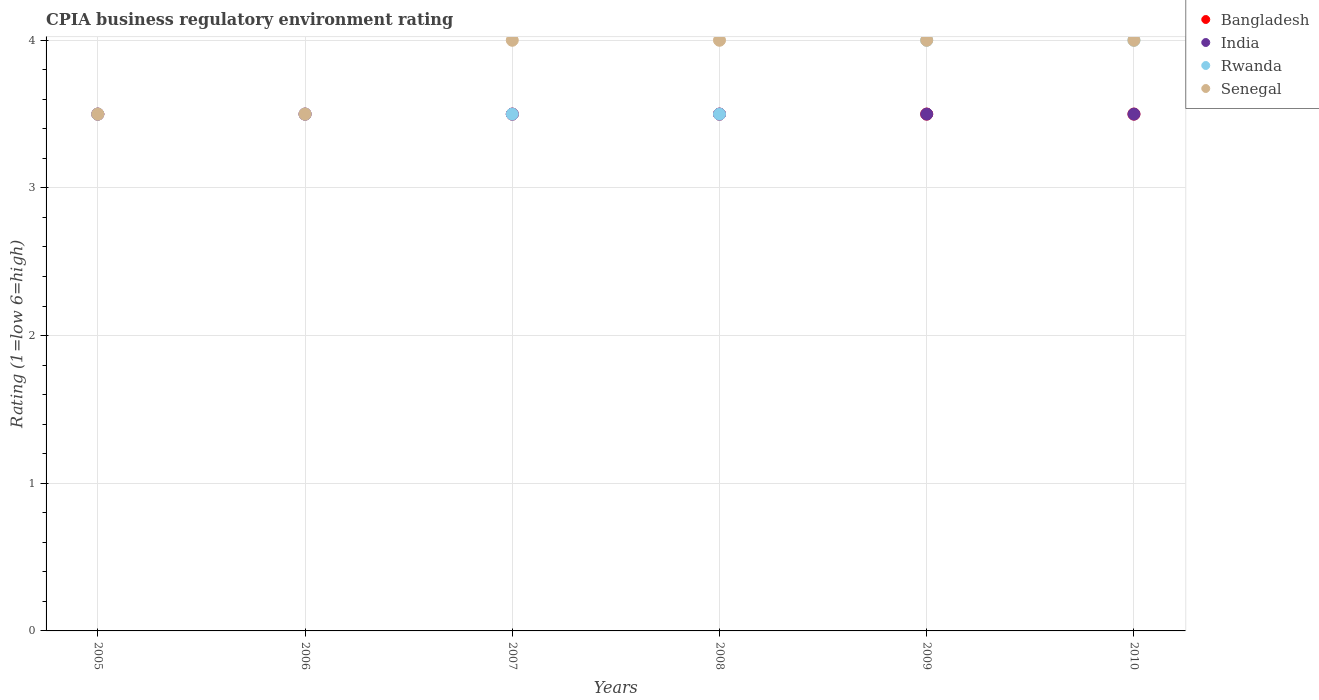How many different coloured dotlines are there?
Your response must be concise. 4. Across all years, what is the minimum CPIA rating in Senegal?
Provide a short and direct response. 3.5. In which year was the CPIA rating in India maximum?
Provide a succinct answer. 2005. In which year was the CPIA rating in Bangladesh minimum?
Provide a short and direct response. 2005. What is the difference between the CPIA rating in Bangladesh in 2005 and that in 2007?
Offer a very short reply. 0. What is the average CPIA rating in Bangladesh per year?
Provide a succinct answer. 3.5. In the year 2009, what is the difference between the CPIA rating in India and CPIA rating in Bangladesh?
Ensure brevity in your answer.  0. What is the ratio of the CPIA rating in Bangladesh in 2005 to that in 2010?
Your answer should be very brief. 1. Is the CPIA rating in India in 2007 less than that in 2009?
Provide a succinct answer. No. Is the difference between the CPIA rating in India in 2009 and 2010 greater than the difference between the CPIA rating in Bangladesh in 2009 and 2010?
Provide a short and direct response. No. Is it the case that in every year, the sum of the CPIA rating in Rwanda and CPIA rating in Bangladesh  is greater than the CPIA rating in India?
Keep it short and to the point. Yes. Does the CPIA rating in Rwanda monotonically increase over the years?
Give a very brief answer. No. How many dotlines are there?
Offer a terse response. 4. What is the difference between two consecutive major ticks on the Y-axis?
Give a very brief answer. 1. Are the values on the major ticks of Y-axis written in scientific E-notation?
Your answer should be very brief. No. Does the graph contain any zero values?
Ensure brevity in your answer.  No. Does the graph contain grids?
Provide a succinct answer. Yes. How many legend labels are there?
Offer a very short reply. 4. What is the title of the graph?
Provide a succinct answer. CPIA business regulatory environment rating. Does "Mozambique" appear as one of the legend labels in the graph?
Offer a very short reply. No. What is the label or title of the Y-axis?
Your answer should be compact. Rating (1=low 6=high). What is the Rating (1=low 6=high) in India in 2005?
Your answer should be compact. 3.5. What is the Rating (1=low 6=high) of Senegal in 2005?
Your answer should be compact. 3.5. What is the Rating (1=low 6=high) of Bangladesh in 2006?
Give a very brief answer. 3.5. What is the Rating (1=low 6=high) of India in 2006?
Provide a short and direct response. 3.5. What is the Rating (1=low 6=high) of Bangladesh in 2008?
Offer a very short reply. 3.5. What is the Rating (1=low 6=high) of Rwanda in 2008?
Offer a very short reply. 3.5. What is the Rating (1=low 6=high) of Senegal in 2008?
Offer a terse response. 4. What is the Rating (1=low 6=high) in Bangladesh in 2009?
Provide a succinct answer. 3.5. What is the Rating (1=low 6=high) of India in 2009?
Keep it short and to the point. 3.5. What is the Rating (1=low 6=high) of Rwanda in 2009?
Provide a succinct answer. 4. What is the Rating (1=low 6=high) of India in 2010?
Give a very brief answer. 3.5. What is the Rating (1=low 6=high) of Rwanda in 2010?
Keep it short and to the point. 4. Across all years, what is the maximum Rating (1=low 6=high) of Senegal?
Provide a succinct answer. 4. Across all years, what is the minimum Rating (1=low 6=high) of Bangladesh?
Provide a short and direct response. 3.5. Across all years, what is the minimum Rating (1=low 6=high) in Rwanda?
Provide a short and direct response. 3.5. What is the total Rating (1=low 6=high) of Bangladesh in the graph?
Your response must be concise. 21. What is the total Rating (1=low 6=high) of India in the graph?
Your answer should be very brief. 21. What is the total Rating (1=low 6=high) in Senegal in the graph?
Your answer should be very brief. 23. What is the difference between the Rating (1=low 6=high) in India in 2005 and that in 2006?
Your answer should be compact. 0. What is the difference between the Rating (1=low 6=high) in Bangladesh in 2005 and that in 2007?
Your answer should be compact. 0. What is the difference between the Rating (1=low 6=high) of Bangladesh in 2005 and that in 2008?
Provide a short and direct response. 0. What is the difference between the Rating (1=low 6=high) of India in 2005 and that in 2008?
Your answer should be very brief. 0. What is the difference between the Rating (1=low 6=high) of Rwanda in 2005 and that in 2008?
Ensure brevity in your answer.  0. What is the difference between the Rating (1=low 6=high) in Senegal in 2005 and that in 2008?
Give a very brief answer. -0.5. What is the difference between the Rating (1=low 6=high) of Bangladesh in 2005 and that in 2010?
Offer a terse response. 0. What is the difference between the Rating (1=low 6=high) in Rwanda in 2005 and that in 2010?
Provide a succinct answer. -0.5. What is the difference between the Rating (1=low 6=high) of India in 2006 and that in 2007?
Provide a short and direct response. 0. What is the difference between the Rating (1=low 6=high) in Bangladesh in 2006 and that in 2008?
Your response must be concise. 0. What is the difference between the Rating (1=low 6=high) of Rwanda in 2006 and that in 2008?
Your answer should be compact. 0. What is the difference between the Rating (1=low 6=high) in Senegal in 2006 and that in 2008?
Make the answer very short. -0.5. What is the difference between the Rating (1=low 6=high) of India in 2006 and that in 2009?
Your answer should be very brief. 0. What is the difference between the Rating (1=low 6=high) of Bangladesh in 2006 and that in 2010?
Your answer should be very brief. 0. What is the difference between the Rating (1=low 6=high) in Rwanda in 2006 and that in 2010?
Give a very brief answer. -0.5. What is the difference between the Rating (1=low 6=high) of Senegal in 2006 and that in 2010?
Ensure brevity in your answer.  -0.5. What is the difference between the Rating (1=low 6=high) of Bangladesh in 2007 and that in 2008?
Ensure brevity in your answer.  0. What is the difference between the Rating (1=low 6=high) in Bangladesh in 2007 and that in 2009?
Keep it short and to the point. 0. What is the difference between the Rating (1=low 6=high) in India in 2007 and that in 2009?
Make the answer very short. 0. What is the difference between the Rating (1=low 6=high) in Rwanda in 2007 and that in 2010?
Provide a succinct answer. -0.5. What is the difference between the Rating (1=low 6=high) of Senegal in 2007 and that in 2010?
Keep it short and to the point. 0. What is the difference between the Rating (1=low 6=high) of Bangladesh in 2008 and that in 2009?
Your answer should be compact. 0. What is the difference between the Rating (1=low 6=high) of Bangladesh in 2009 and that in 2010?
Offer a terse response. 0. What is the difference between the Rating (1=low 6=high) in India in 2009 and that in 2010?
Make the answer very short. 0. What is the difference between the Rating (1=low 6=high) of Rwanda in 2009 and that in 2010?
Offer a very short reply. 0. What is the difference between the Rating (1=low 6=high) of Bangladesh in 2005 and the Rating (1=low 6=high) of India in 2006?
Offer a terse response. 0. What is the difference between the Rating (1=low 6=high) of Bangladesh in 2005 and the Rating (1=low 6=high) of Rwanda in 2006?
Provide a succinct answer. 0. What is the difference between the Rating (1=low 6=high) of India in 2005 and the Rating (1=low 6=high) of Rwanda in 2006?
Make the answer very short. 0. What is the difference between the Rating (1=low 6=high) of India in 2005 and the Rating (1=low 6=high) of Senegal in 2006?
Keep it short and to the point. 0. What is the difference between the Rating (1=low 6=high) of Bangladesh in 2005 and the Rating (1=low 6=high) of Senegal in 2007?
Provide a short and direct response. -0.5. What is the difference between the Rating (1=low 6=high) of India in 2005 and the Rating (1=low 6=high) of Rwanda in 2007?
Provide a succinct answer. 0. What is the difference between the Rating (1=low 6=high) in Rwanda in 2005 and the Rating (1=low 6=high) in Senegal in 2008?
Your answer should be very brief. -0.5. What is the difference between the Rating (1=low 6=high) of Bangladesh in 2005 and the Rating (1=low 6=high) of Rwanda in 2009?
Your answer should be compact. -0.5. What is the difference between the Rating (1=low 6=high) in India in 2005 and the Rating (1=low 6=high) in Rwanda in 2009?
Your answer should be compact. -0.5. What is the difference between the Rating (1=low 6=high) in India in 2005 and the Rating (1=low 6=high) in Senegal in 2009?
Your answer should be compact. -0.5. What is the difference between the Rating (1=low 6=high) of Rwanda in 2005 and the Rating (1=low 6=high) of Senegal in 2009?
Offer a very short reply. -0.5. What is the difference between the Rating (1=low 6=high) in Bangladesh in 2005 and the Rating (1=low 6=high) in India in 2010?
Keep it short and to the point. 0. What is the difference between the Rating (1=low 6=high) of Bangladesh in 2005 and the Rating (1=low 6=high) of Senegal in 2010?
Your answer should be very brief. -0.5. What is the difference between the Rating (1=low 6=high) in India in 2005 and the Rating (1=low 6=high) in Senegal in 2010?
Offer a very short reply. -0.5. What is the difference between the Rating (1=low 6=high) in Rwanda in 2005 and the Rating (1=low 6=high) in Senegal in 2010?
Provide a short and direct response. -0.5. What is the difference between the Rating (1=low 6=high) in Bangladesh in 2006 and the Rating (1=low 6=high) in Rwanda in 2007?
Your answer should be compact. 0. What is the difference between the Rating (1=low 6=high) in Bangladesh in 2006 and the Rating (1=low 6=high) in India in 2008?
Your answer should be compact. 0. What is the difference between the Rating (1=low 6=high) of Bangladesh in 2006 and the Rating (1=low 6=high) of Senegal in 2008?
Keep it short and to the point. -0.5. What is the difference between the Rating (1=low 6=high) in Rwanda in 2006 and the Rating (1=low 6=high) in Senegal in 2008?
Your response must be concise. -0.5. What is the difference between the Rating (1=low 6=high) in Bangladesh in 2006 and the Rating (1=low 6=high) in India in 2009?
Provide a short and direct response. 0. What is the difference between the Rating (1=low 6=high) in Bangladesh in 2006 and the Rating (1=low 6=high) in Rwanda in 2009?
Provide a succinct answer. -0.5. What is the difference between the Rating (1=low 6=high) of Bangladesh in 2006 and the Rating (1=low 6=high) of Senegal in 2009?
Keep it short and to the point. -0.5. What is the difference between the Rating (1=low 6=high) of Rwanda in 2006 and the Rating (1=low 6=high) of Senegal in 2009?
Offer a very short reply. -0.5. What is the difference between the Rating (1=low 6=high) in Bangladesh in 2006 and the Rating (1=low 6=high) in India in 2010?
Give a very brief answer. 0. What is the difference between the Rating (1=low 6=high) of Bangladesh in 2006 and the Rating (1=low 6=high) of Senegal in 2010?
Give a very brief answer. -0.5. What is the difference between the Rating (1=low 6=high) of India in 2006 and the Rating (1=low 6=high) of Rwanda in 2010?
Provide a short and direct response. -0.5. What is the difference between the Rating (1=low 6=high) of Bangladesh in 2007 and the Rating (1=low 6=high) of India in 2008?
Your answer should be compact. 0. What is the difference between the Rating (1=low 6=high) of Bangladesh in 2007 and the Rating (1=low 6=high) of Rwanda in 2008?
Make the answer very short. 0. What is the difference between the Rating (1=low 6=high) in Bangladesh in 2007 and the Rating (1=low 6=high) in Senegal in 2008?
Give a very brief answer. -0.5. What is the difference between the Rating (1=low 6=high) in India in 2007 and the Rating (1=low 6=high) in Rwanda in 2008?
Offer a very short reply. 0. What is the difference between the Rating (1=low 6=high) of India in 2007 and the Rating (1=low 6=high) of Senegal in 2008?
Make the answer very short. -0.5. What is the difference between the Rating (1=low 6=high) of Bangladesh in 2007 and the Rating (1=low 6=high) of Rwanda in 2009?
Keep it short and to the point. -0.5. What is the difference between the Rating (1=low 6=high) in Bangladesh in 2007 and the Rating (1=low 6=high) in Senegal in 2009?
Give a very brief answer. -0.5. What is the difference between the Rating (1=low 6=high) in India in 2007 and the Rating (1=low 6=high) in Rwanda in 2009?
Provide a short and direct response. -0.5. What is the difference between the Rating (1=low 6=high) in India in 2007 and the Rating (1=low 6=high) in Senegal in 2009?
Your response must be concise. -0.5. What is the difference between the Rating (1=low 6=high) in Rwanda in 2007 and the Rating (1=low 6=high) in Senegal in 2009?
Make the answer very short. -0.5. What is the difference between the Rating (1=low 6=high) in Bangladesh in 2008 and the Rating (1=low 6=high) in India in 2009?
Your answer should be compact. 0. What is the difference between the Rating (1=low 6=high) of Bangladesh in 2008 and the Rating (1=low 6=high) of Rwanda in 2009?
Your answer should be compact. -0.5. What is the difference between the Rating (1=low 6=high) of Rwanda in 2008 and the Rating (1=low 6=high) of Senegal in 2009?
Make the answer very short. -0.5. What is the difference between the Rating (1=low 6=high) in Bangladesh in 2008 and the Rating (1=low 6=high) in Senegal in 2010?
Keep it short and to the point. -0.5. What is the difference between the Rating (1=low 6=high) in Rwanda in 2008 and the Rating (1=low 6=high) in Senegal in 2010?
Make the answer very short. -0.5. What is the difference between the Rating (1=low 6=high) of Bangladesh in 2009 and the Rating (1=low 6=high) of India in 2010?
Ensure brevity in your answer.  0. What is the difference between the Rating (1=low 6=high) in India in 2009 and the Rating (1=low 6=high) in Senegal in 2010?
Your answer should be very brief. -0.5. What is the difference between the Rating (1=low 6=high) in Rwanda in 2009 and the Rating (1=low 6=high) in Senegal in 2010?
Offer a terse response. 0. What is the average Rating (1=low 6=high) of Rwanda per year?
Your answer should be compact. 3.67. What is the average Rating (1=low 6=high) in Senegal per year?
Your response must be concise. 3.83. In the year 2005, what is the difference between the Rating (1=low 6=high) of Bangladesh and Rating (1=low 6=high) of Rwanda?
Provide a succinct answer. 0. In the year 2005, what is the difference between the Rating (1=low 6=high) of India and Rating (1=low 6=high) of Senegal?
Your answer should be compact. 0. In the year 2006, what is the difference between the Rating (1=low 6=high) in Bangladesh and Rating (1=low 6=high) in India?
Your response must be concise. 0. In the year 2006, what is the difference between the Rating (1=low 6=high) in Bangladesh and Rating (1=low 6=high) in Senegal?
Offer a very short reply. 0. In the year 2007, what is the difference between the Rating (1=low 6=high) of Bangladesh and Rating (1=low 6=high) of Rwanda?
Your answer should be very brief. 0. In the year 2007, what is the difference between the Rating (1=low 6=high) of Bangladesh and Rating (1=low 6=high) of Senegal?
Your answer should be compact. -0.5. In the year 2007, what is the difference between the Rating (1=low 6=high) in India and Rating (1=low 6=high) in Senegal?
Provide a short and direct response. -0.5. In the year 2008, what is the difference between the Rating (1=low 6=high) of Bangladesh and Rating (1=low 6=high) of Rwanda?
Your answer should be very brief. 0. In the year 2008, what is the difference between the Rating (1=low 6=high) of Rwanda and Rating (1=low 6=high) of Senegal?
Your response must be concise. -0.5. In the year 2009, what is the difference between the Rating (1=low 6=high) in Bangladesh and Rating (1=low 6=high) in India?
Keep it short and to the point. 0. In the year 2009, what is the difference between the Rating (1=low 6=high) of India and Rating (1=low 6=high) of Senegal?
Offer a very short reply. -0.5. In the year 2009, what is the difference between the Rating (1=low 6=high) of Rwanda and Rating (1=low 6=high) of Senegal?
Give a very brief answer. 0. In the year 2010, what is the difference between the Rating (1=low 6=high) of Bangladesh and Rating (1=low 6=high) of Senegal?
Offer a terse response. -0.5. What is the ratio of the Rating (1=low 6=high) of Bangladesh in 2005 to that in 2006?
Your answer should be very brief. 1. What is the ratio of the Rating (1=low 6=high) in India in 2005 to that in 2006?
Ensure brevity in your answer.  1. What is the ratio of the Rating (1=low 6=high) in Rwanda in 2005 to that in 2006?
Make the answer very short. 1. What is the ratio of the Rating (1=low 6=high) in Senegal in 2005 to that in 2006?
Offer a terse response. 1. What is the ratio of the Rating (1=low 6=high) of Bangladesh in 2005 to that in 2007?
Your response must be concise. 1. What is the ratio of the Rating (1=low 6=high) of Senegal in 2005 to that in 2008?
Your answer should be very brief. 0.88. What is the ratio of the Rating (1=low 6=high) in Bangladesh in 2005 to that in 2009?
Keep it short and to the point. 1. What is the ratio of the Rating (1=low 6=high) in India in 2005 to that in 2009?
Make the answer very short. 1. What is the ratio of the Rating (1=low 6=high) in Senegal in 2005 to that in 2009?
Offer a very short reply. 0.88. What is the ratio of the Rating (1=low 6=high) in India in 2005 to that in 2010?
Keep it short and to the point. 1. What is the ratio of the Rating (1=low 6=high) of Bangladesh in 2006 to that in 2007?
Ensure brevity in your answer.  1. What is the ratio of the Rating (1=low 6=high) in India in 2006 to that in 2007?
Your answer should be very brief. 1. What is the ratio of the Rating (1=low 6=high) in Bangladesh in 2006 to that in 2008?
Make the answer very short. 1. What is the ratio of the Rating (1=low 6=high) of India in 2006 to that in 2008?
Your response must be concise. 1. What is the ratio of the Rating (1=low 6=high) in Senegal in 2006 to that in 2008?
Your answer should be very brief. 0.88. What is the ratio of the Rating (1=low 6=high) in India in 2006 to that in 2009?
Offer a very short reply. 1. What is the ratio of the Rating (1=low 6=high) of Senegal in 2006 to that in 2009?
Make the answer very short. 0.88. What is the ratio of the Rating (1=low 6=high) of Bangladesh in 2007 to that in 2008?
Provide a succinct answer. 1. What is the ratio of the Rating (1=low 6=high) of Rwanda in 2007 to that in 2008?
Give a very brief answer. 1. What is the ratio of the Rating (1=low 6=high) in Bangladesh in 2007 to that in 2009?
Your response must be concise. 1. What is the ratio of the Rating (1=low 6=high) of Rwanda in 2007 to that in 2009?
Provide a succinct answer. 0.88. What is the ratio of the Rating (1=low 6=high) of Senegal in 2007 to that in 2009?
Your response must be concise. 1. What is the ratio of the Rating (1=low 6=high) of Bangladesh in 2008 to that in 2009?
Your response must be concise. 1. What is the ratio of the Rating (1=low 6=high) of Senegal in 2008 to that in 2010?
Your response must be concise. 1. What is the ratio of the Rating (1=low 6=high) of Bangladesh in 2009 to that in 2010?
Your answer should be very brief. 1. What is the ratio of the Rating (1=low 6=high) in Senegal in 2009 to that in 2010?
Your answer should be compact. 1. What is the difference between the highest and the second highest Rating (1=low 6=high) of Rwanda?
Your response must be concise. 0. What is the difference between the highest and the second highest Rating (1=low 6=high) in Senegal?
Make the answer very short. 0. What is the difference between the highest and the lowest Rating (1=low 6=high) of Bangladesh?
Give a very brief answer. 0. What is the difference between the highest and the lowest Rating (1=low 6=high) in Senegal?
Keep it short and to the point. 0.5. 